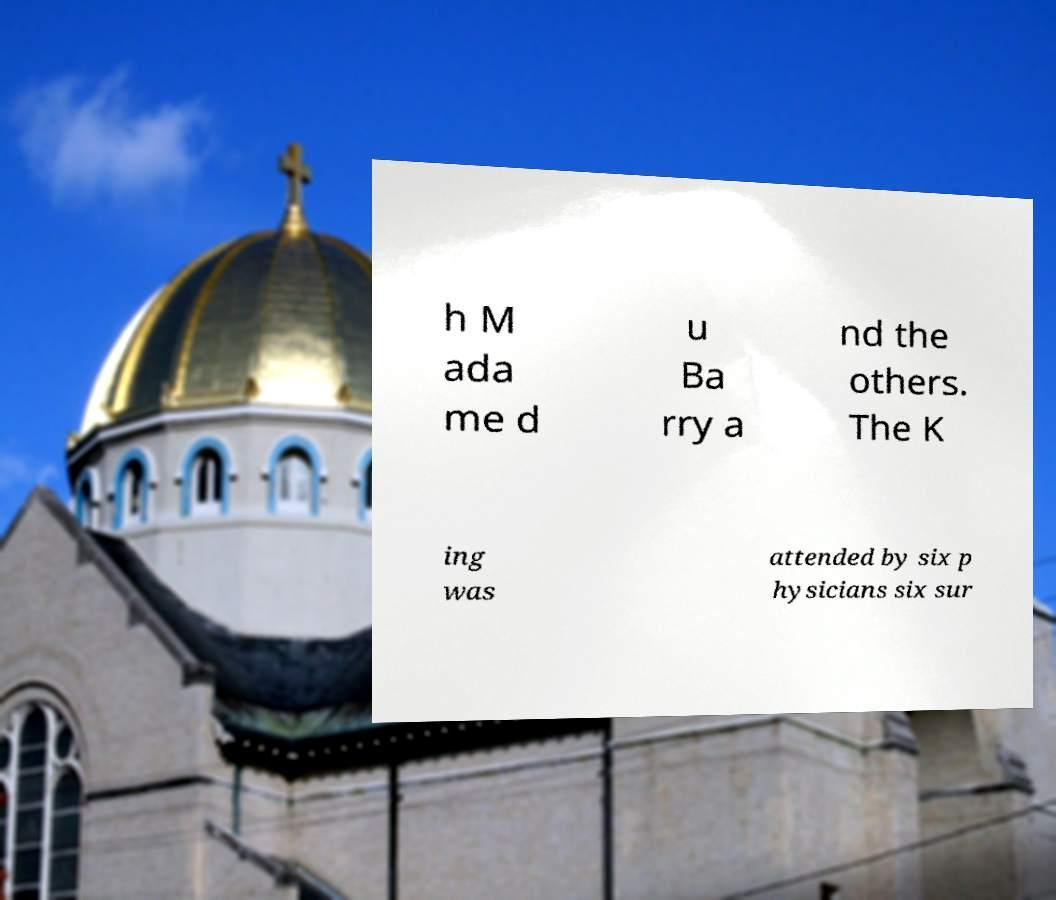Can you accurately transcribe the text from the provided image for me? h M ada me d u Ba rry a nd the others. The K ing was attended by six p hysicians six sur 